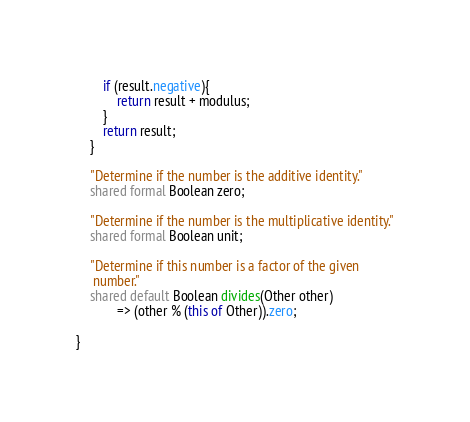<code> <loc_0><loc_0><loc_500><loc_500><_Ceylon_>        if (result.negative){
            return result + modulus;
        }
        return result;
    }
    
    "Determine if the number is the additive identity."
    shared formal Boolean zero;
    
    "Determine if the number is the multiplicative identity."
    shared formal Boolean unit;
    
    "Determine if this number is a factor of the given 
     number."
    shared default Boolean divides(Other other) 
            => (other % (this of Other)).zero;
    
}
</code> 